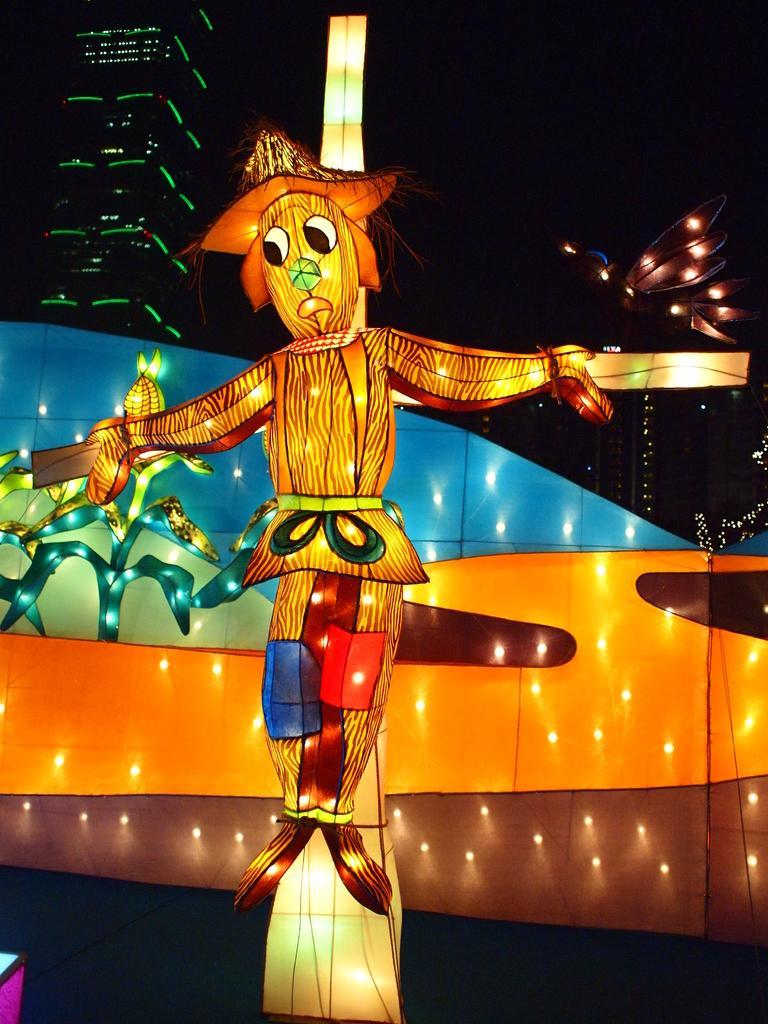In one or two sentences, can you explain what this image depicts? In the picture there is a statue of a cartoon and there are a lot of lights kept around that cartoon and in the background there is a building. 